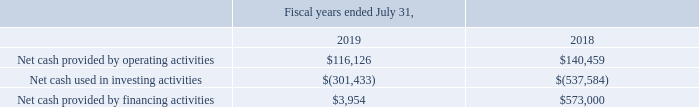Cash Flows
Our cash flows from operations are significantly impacted by timing of invoicing and collections of accounts receivable and annual bonus payments, as well as payments of payroll, payroll taxes, and other taxes.
We expect that we will continue to generate positive cash flows from operations on an annual basis, although this may fluctuate significantly on a quarterly basis. In particular, we typically use more cash during the first fiscal quarter ended October 31, as we generally pay cash bonuses to our employees for the prior fiscal year during that period and pay seasonally higher sales commissions from increased customer orders booked in our fourth fiscal quarter.
We believe that our existing cash and cash equivalents and sources of liquidity will be sufficient to fund our operations for at least the next 12 months. Our future capital requirements will depend on many factors, including our rate of revenue growth, the expansion of our sales and marketing activities, the timing and extent of our spending to support our research and development efforts, investments in cloud infrastructure and operating costs, and expansion into other markets.
We also may invest in or acquire complementary businesses, applications, or technologies, which may require the use of significant cash resources and/or additional financing. The following summary of cash flows for the periods indicated has been derived from our consolidated financial statements included elsewhere in this Annual Report on Form 10-K (in thousands):
What were the cash flows from operations impacted by? By timing of invoicing and collections of accounts receivable and annual bonus payments, as well as payments of payroll, payroll taxes, and other taxes. What was the Net cash provided by financing activities in 2019 and 2018 respectively?
Answer scale should be: thousand. $3,954, $573,000. What was the Net cash provided by operating activities in 2019 and 2018 respectively?
Answer scale should be: thousand. $116,126, $140,459. What was the average Net cash provided by operating activities for 2018 and 2019?
Answer scale should be: thousand. (116,126 + 140,459) / 2
Answer: 128292.5. What is the change in the Net cash provided by financing activities from 2018 to 2019?
Answer scale should be: thousand. 3,954 - 573,000
Answer: -569046. In which year was Net cash used in investing activities less than -350,000 thousands? Locate and analyze net cash used in investing activities in row 4
answer: 2019. 